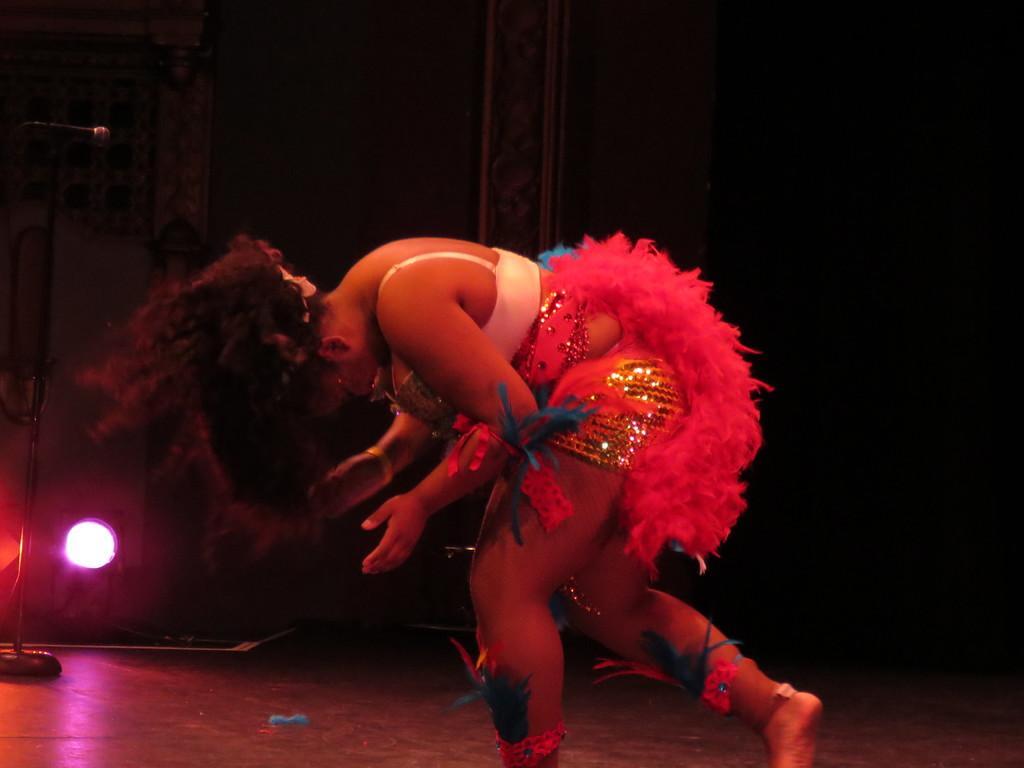Describe this image in one or two sentences. There is one woman standing on the floor as we can see in the middle of this image. It is dark in the background. There is a light and Mike present on the left side of this image. 